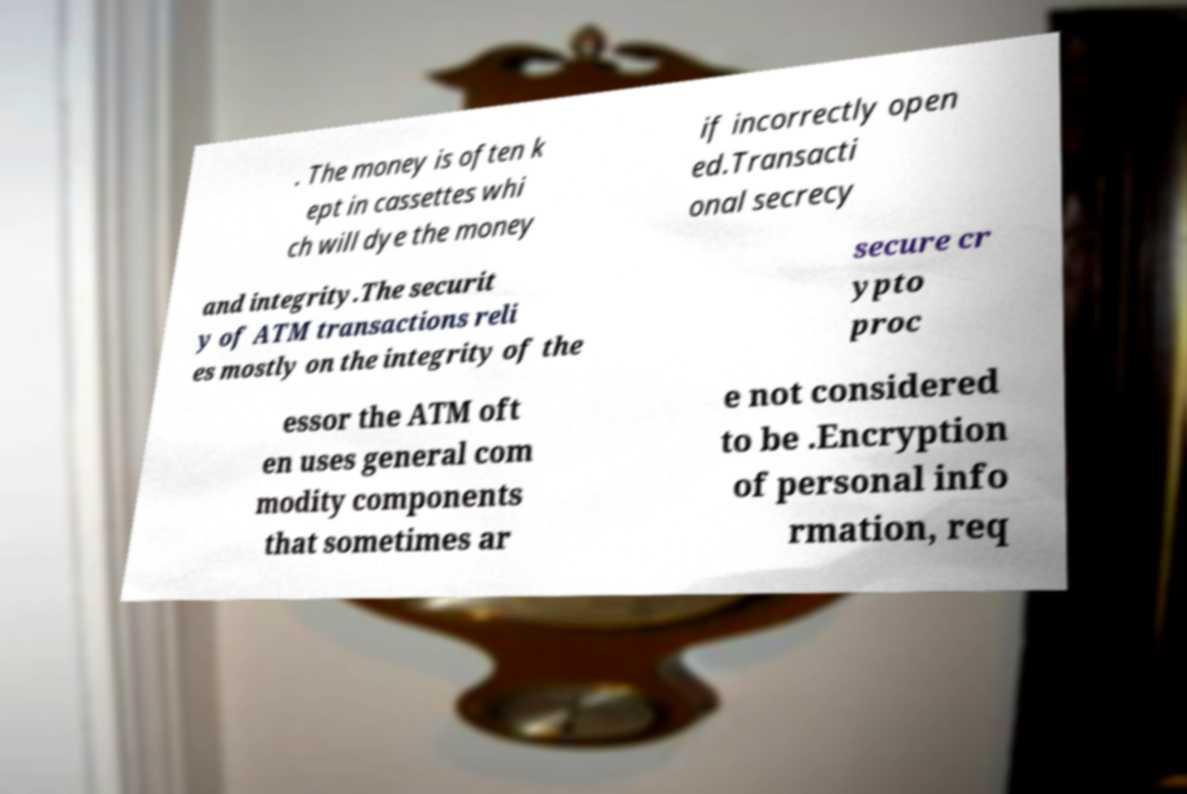Could you extract and type out the text from this image? . The money is often k ept in cassettes whi ch will dye the money if incorrectly open ed.Transacti onal secrecy and integrity.The securit y of ATM transactions reli es mostly on the integrity of the secure cr ypto proc essor the ATM oft en uses general com modity components that sometimes ar e not considered to be .Encryption of personal info rmation, req 